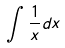<formula> <loc_0><loc_0><loc_500><loc_500>\int \frac { 1 } { x } d x</formula> 